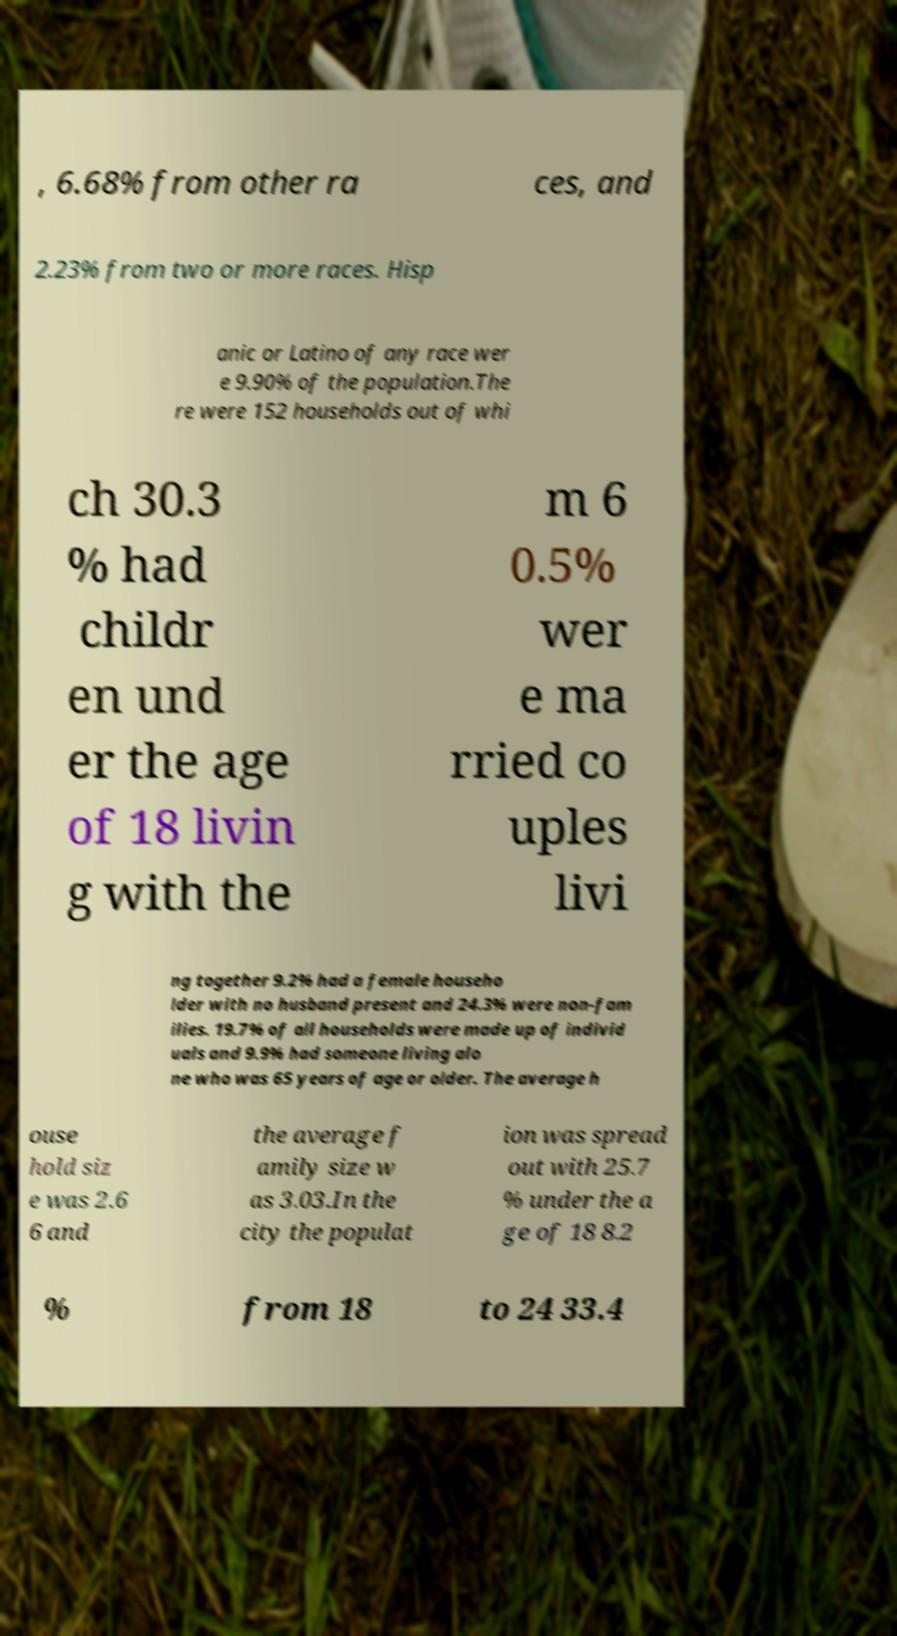Please identify and transcribe the text found in this image. , 6.68% from other ra ces, and 2.23% from two or more races. Hisp anic or Latino of any race wer e 9.90% of the population.The re were 152 households out of whi ch 30.3 % had childr en und er the age of 18 livin g with the m 6 0.5% wer e ma rried co uples livi ng together 9.2% had a female househo lder with no husband present and 24.3% were non-fam ilies. 19.7% of all households were made up of individ uals and 9.9% had someone living alo ne who was 65 years of age or older. The average h ouse hold siz e was 2.6 6 and the average f amily size w as 3.03.In the city the populat ion was spread out with 25.7 % under the a ge of 18 8.2 % from 18 to 24 33.4 